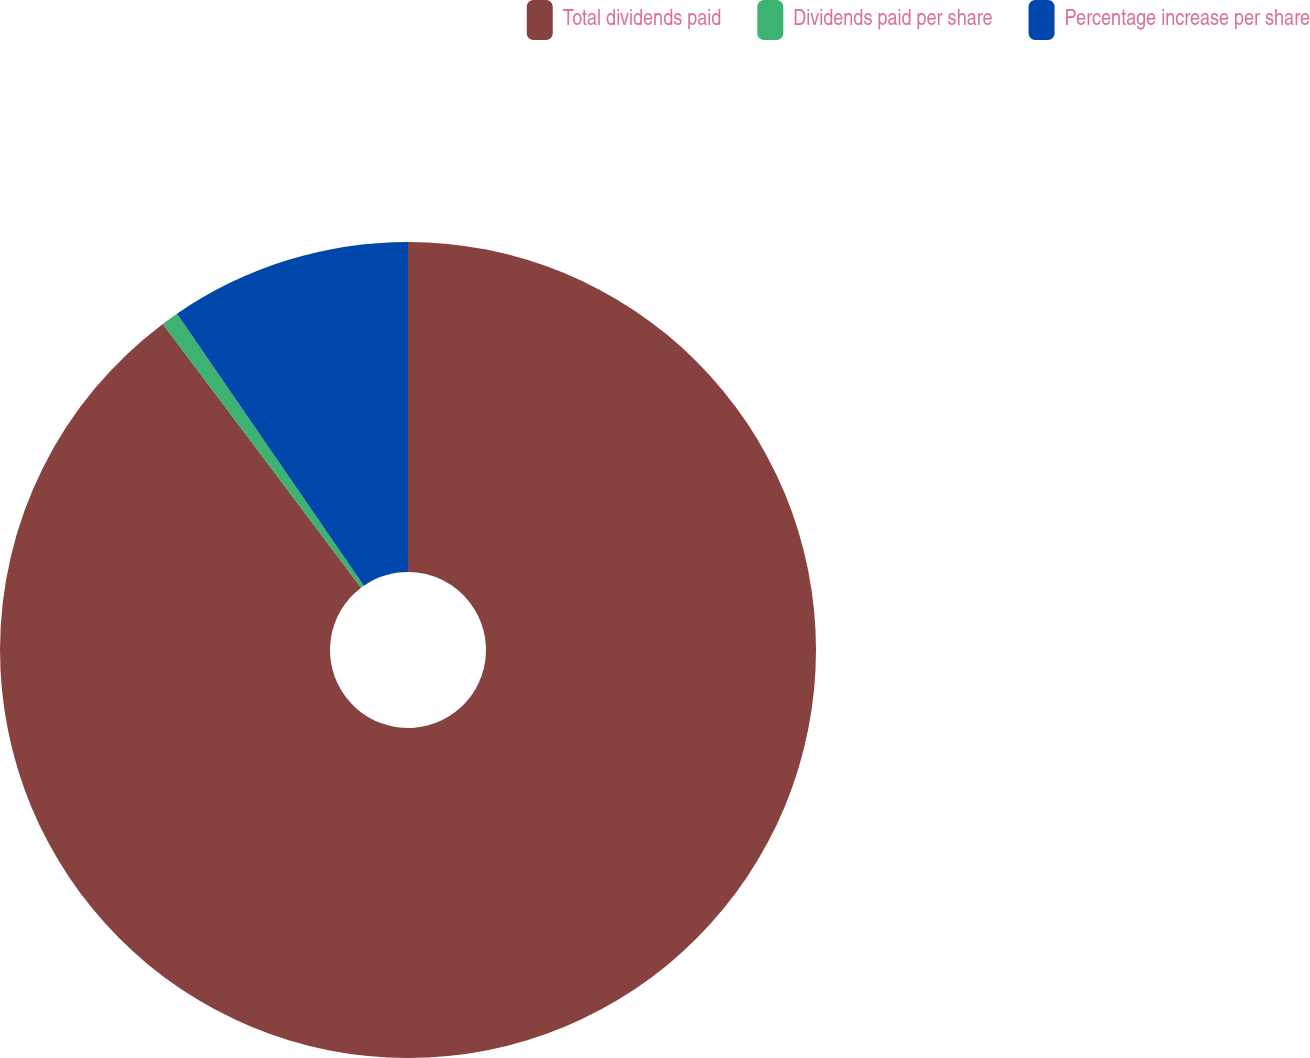Convert chart to OTSL. <chart><loc_0><loc_0><loc_500><loc_500><pie_chart><fcel>Total dividends paid<fcel>Dividends paid per share<fcel>Percentage increase per share<nl><fcel>89.74%<fcel>0.68%<fcel>9.58%<nl></chart> 